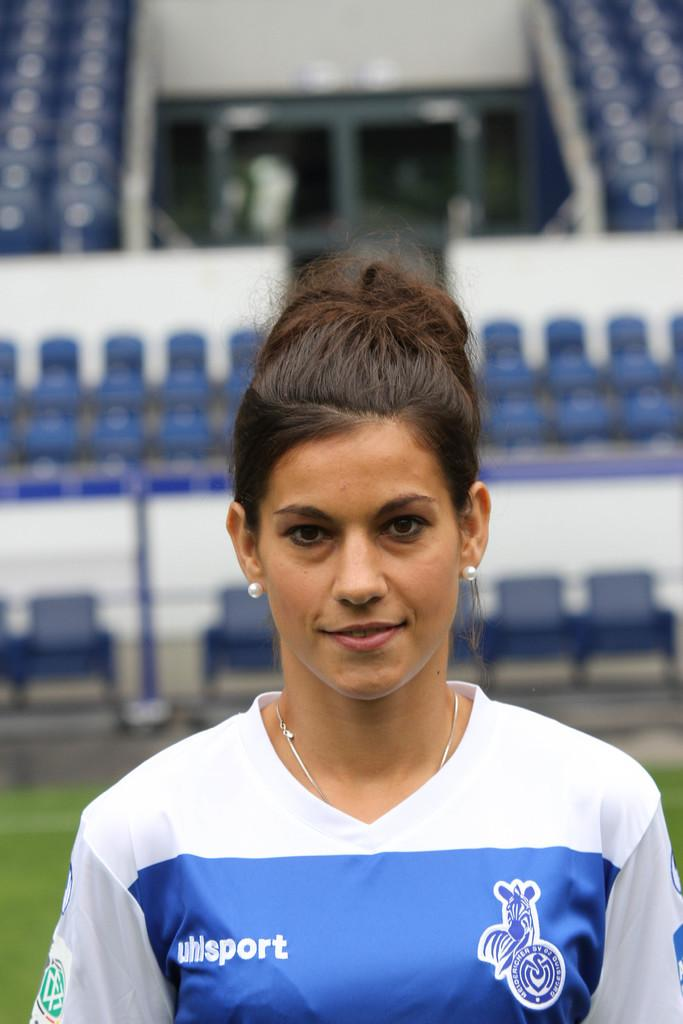<image>
Share a concise interpretation of the image provided. A girl with a blue and white shirt that says uhisport is standing in a sports stadium. 